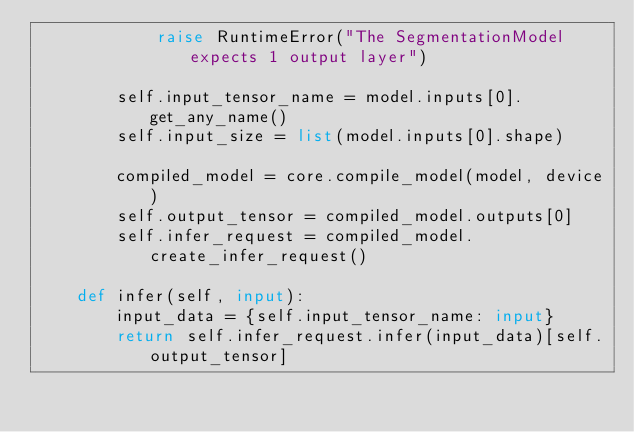Convert code to text. <code><loc_0><loc_0><loc_500><loc_500><_Python_>            raise RuntimeError("The SegmentationModel expects 1 output layer")

        self.input_tensor_name = model.inputs[0].get_any_name()
        self.input_size = list(model.inputs[0].shape)

        compiled_model = core.compile_model(model, device)
        self.output_tensor = compiled_model.outputs[0]
        self.infer_request = compiled_model.create_infer_request()

    def infer(self, input):
        input_data = {self.input_tensor_name: input}
        return self.infer_request.infer(input_data)[self.output_tensor]
</code> 